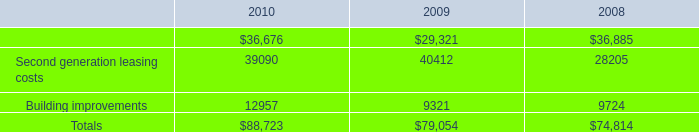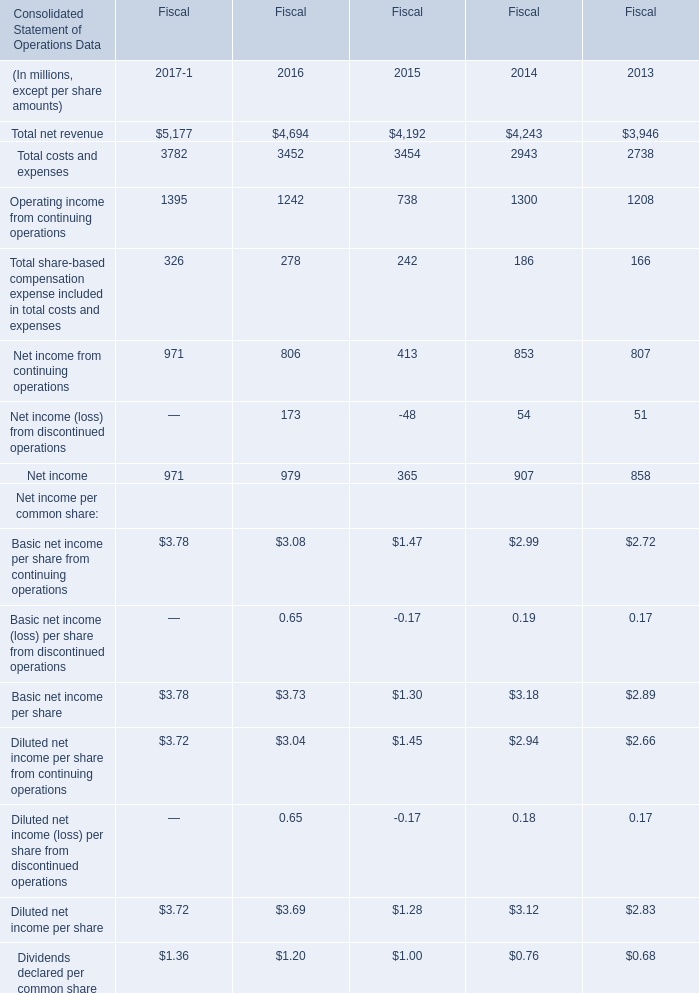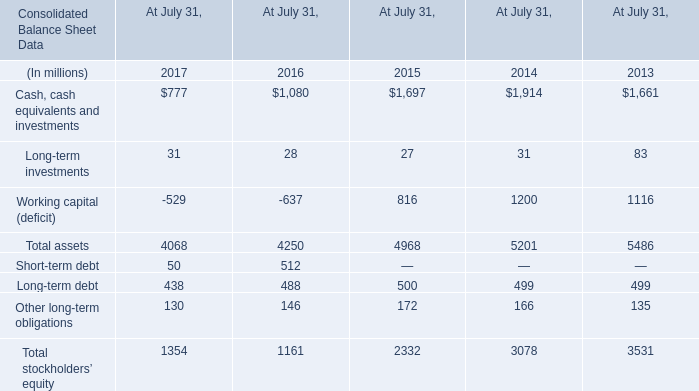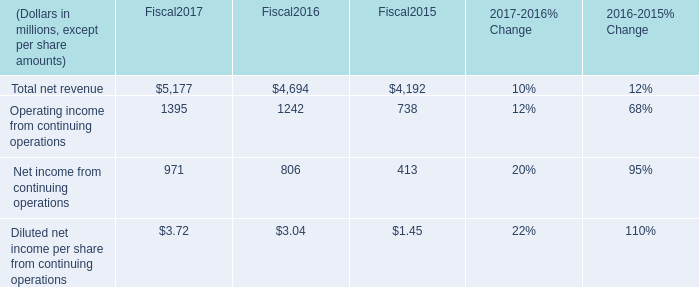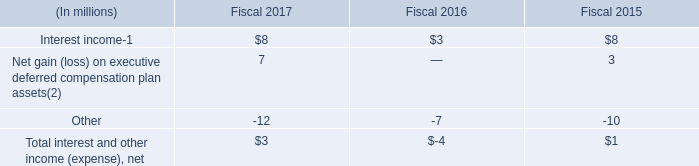Which year is Net income from continuing operations the most? 
Answer: 2017. 